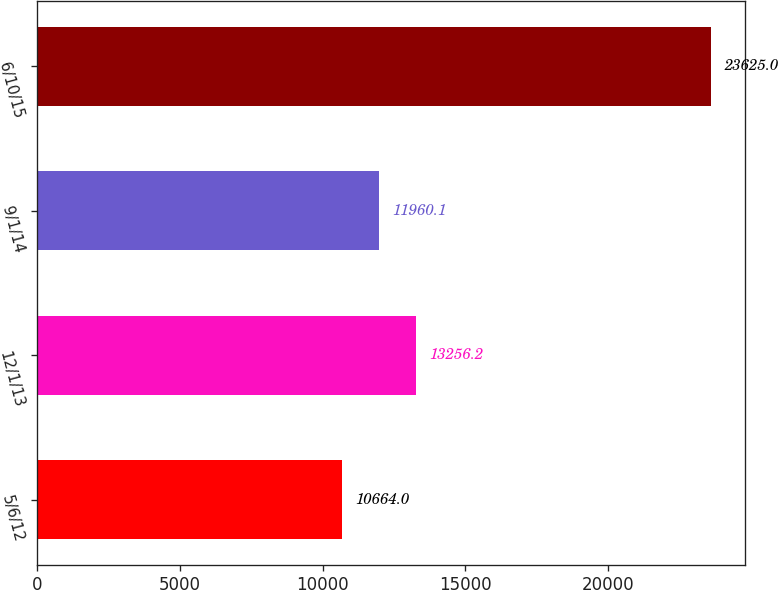<chart> <loc_0><loc_0><loc_500><loc_500><bar_chart><fcel>5/6/12<fcel>12/1/13<fcel>9/1/14<fcel>6/10/15<nl><fcel>10664<fcel>13256.2<fcel>11960.1<fcel>23625<nl></chart> 